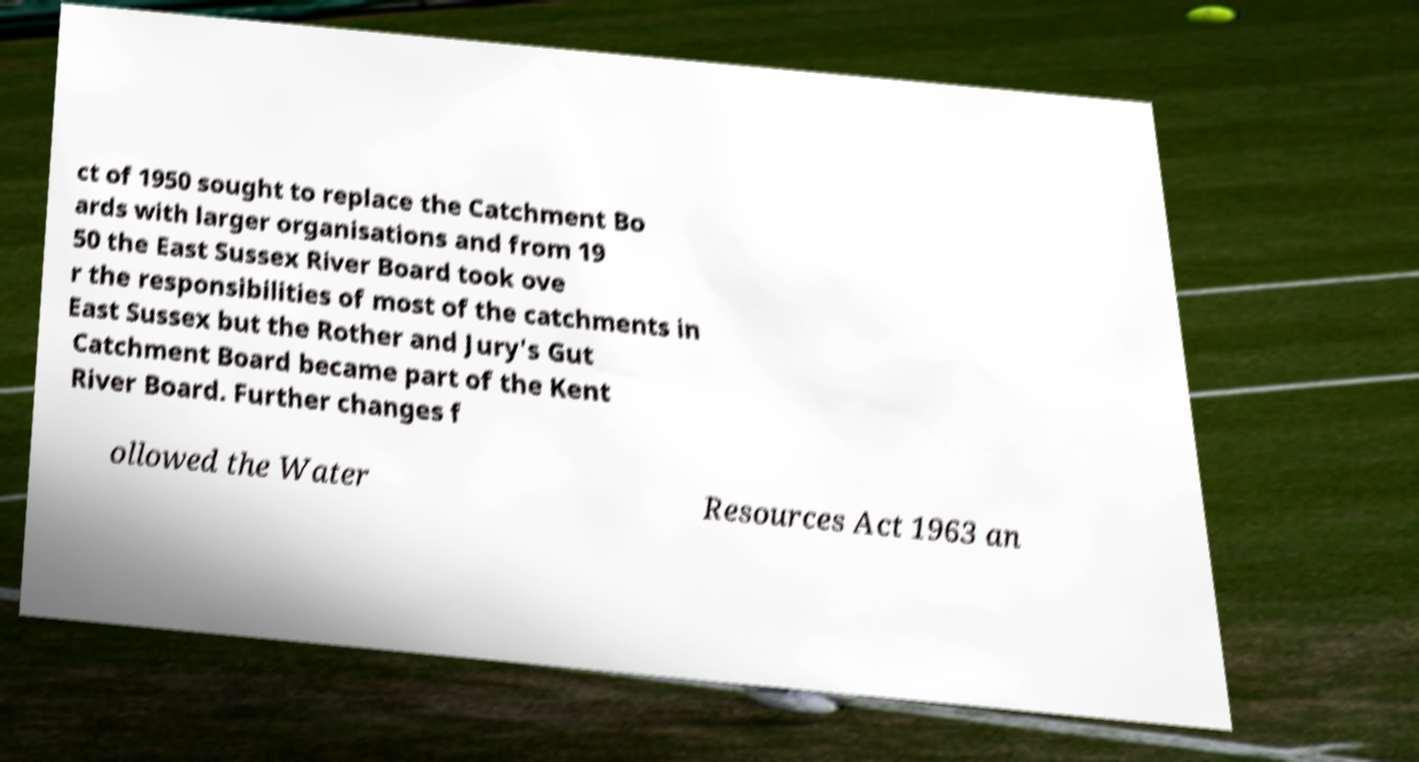Please identify and transcribe the text found in this image. ct of 1950 sought to replace the Catchment Bo ards with larger organisations and from 19 50 the East Sussex River Board took ove r the responsibilities of most of the catchments in East Sussex but the Rother and Jury's Gut Catchment Board became part of the Kent River Board. Further changes f ollowed the Water Resources Act 1963 an 